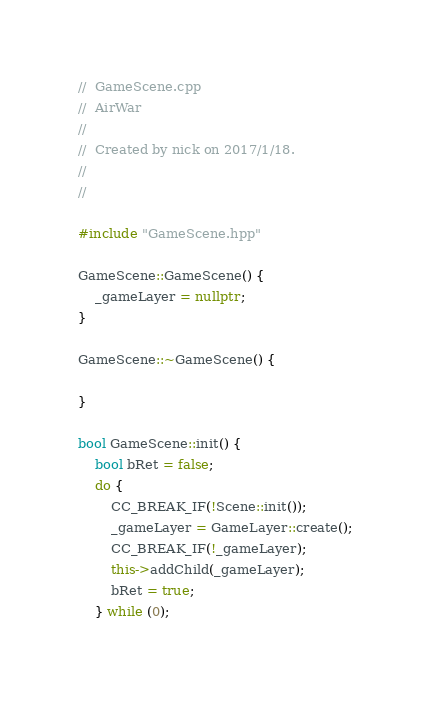Convert code to text. <code><loc_0><loc_0><loc_500><loc_500><_C++_>//  GameScene.cpp
//  AirWar
//
//  Created by nick on 2017/1/18.
//
//

#include "GameScene.hpp"

GameScene::GameScene() {
    _gameLayer = nullptr;
}

GameScene::~GameScene() {
    
}

bool GameScene::init() {
    bool bRet = false;
    do {
        CC_BREAK_IF(!Scene::init());
        _gameLayer = GameLayer::create();
        CC_BREAK_IF(!_gameLayer);
        this->addChild(_gameLayer);
        bRet = true;
    } while (0);</code> 